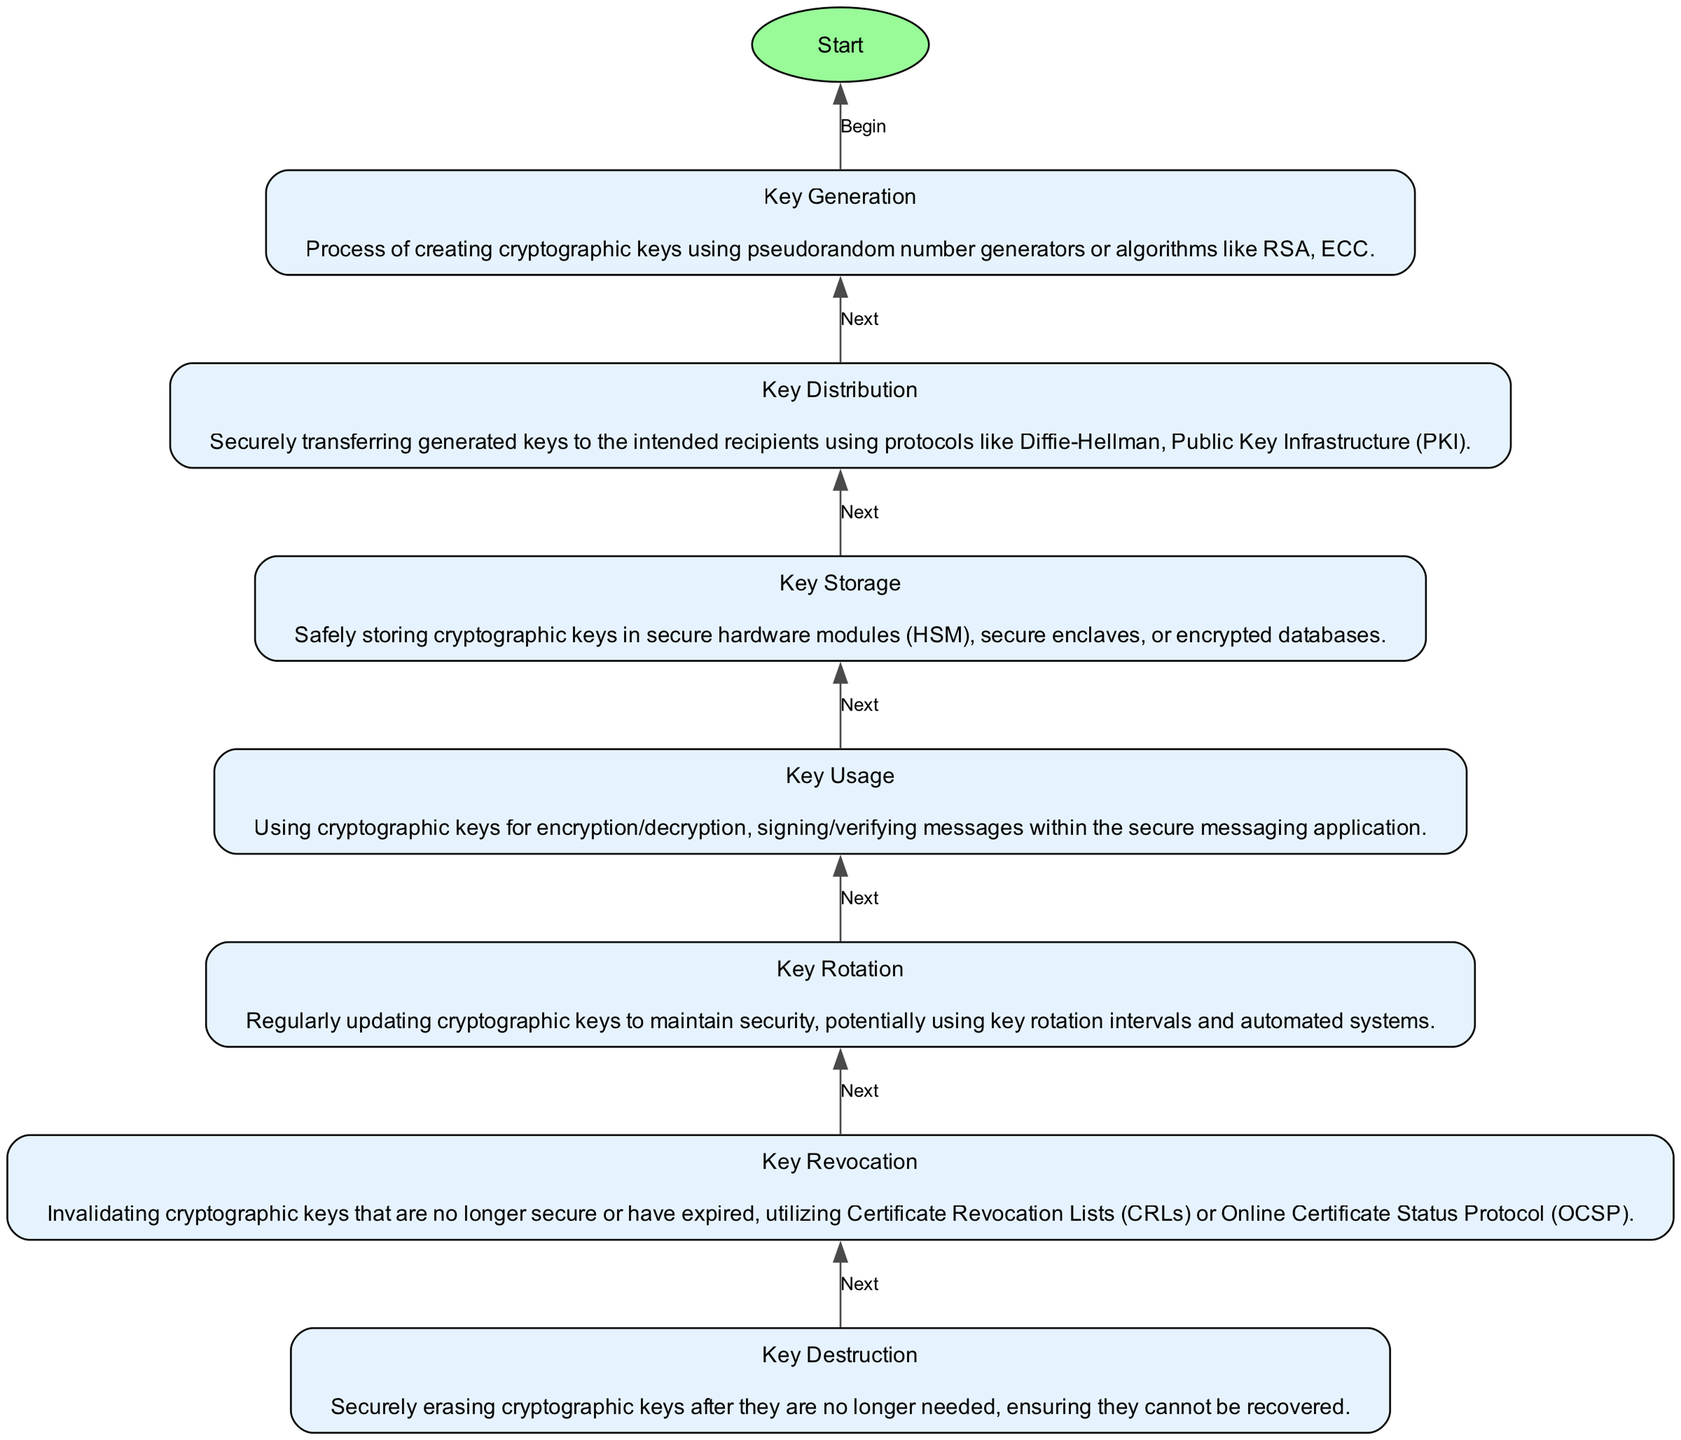What is the first step in the cryptographic key management lifecycle? The first step in the lifecycle, as depicted in the diagram, is "Key Generation." It is the initial node, and all processes flow upward from this point.
Answer: Key Generation Which process follows Key Storage? According to the diagram, after "Key Storage," the next step is "Key Usage," indicating the flow from the storage of keys to their practical application.
Answer: Key Usage How many processes are there in the lifecycle? The diagram lists seven distinct processes, starting from "Key Generation" and ending with "Key Destruction," providing a clear count of the steps involved.
Answer: Seven What happens after Key Revocation? The diagram illustrates that after "Key Revocation," the next process is "Key Destruction," showing the progression towards securely eliminating keys that are no longer in use.
Answer: Key Destruction What is the purpose of Key Rotation? The diagram specifies that "Key Rotation" involves regularly updating cryptographic keys to maintain security, indicating its role in ensuring ongoing protection within the key management lifecycle.
Answer: Regularly updating keys Which node is connected to the Start node? The "Key Generation" node is linked to the "Start" node, portraying that the process begins with key generation in the lifecycle.
Answer: Key Generation What protocol can be used in Key Distribution? The diagram states that secure key distribution can be achieved using protocols like Diffie-Hellman or Public Key Infrastructure (PKI), indicating options available for this process.
Answer: Diffie-Hellman Which two processes are directly connected? The diagram shows that "Key Usage" is directly connected to "Key Rotation," demonstrating the sequence where keys are utilized before being rotated regularly for security.
Answer: Key Usage and Key Rotation What is the end point of the cryptographic key management lifecycle? The final step is "End," which signifies the conclusion of the lifecycle after the secure destruction of cryptographic keys following their obsolescence.
Answer: End 